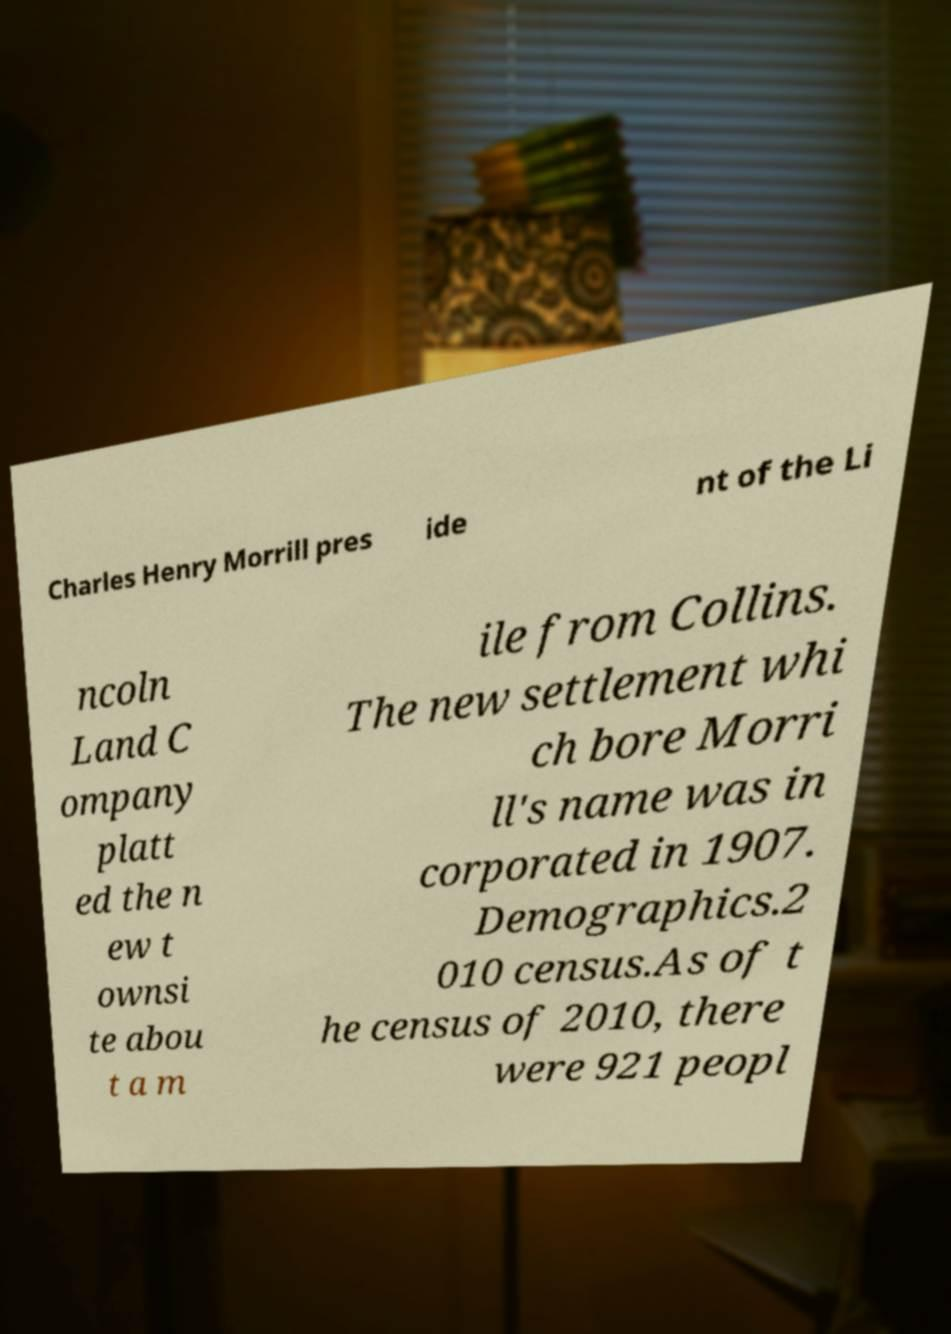For documentation purposes, I need the text within this image transcribed. Could you provide that? Charles Henry Morrill pres ide nt of the Li ncoln Land C ompany platt ed the n ew t ownsi te abou t a m ile from Collins. The new settlement whi ch bore Morri ll's name was in corporated in 1907. Demographics.2 010 census.As of t he census of 2010, there were 921 peopl 